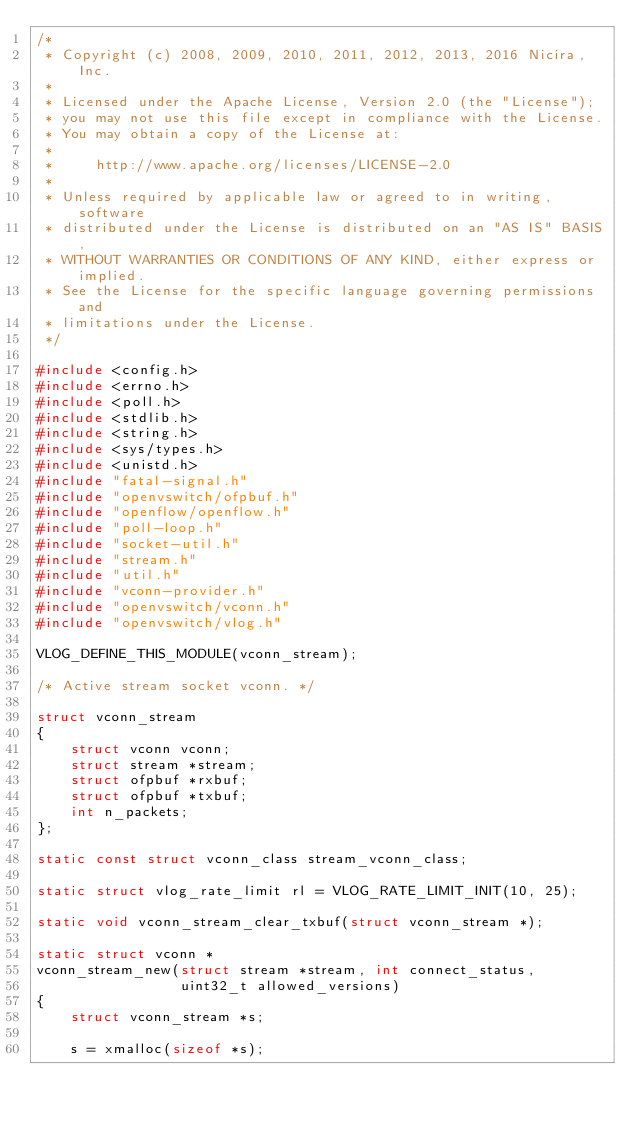<code> <loc_0><loc_0><loc_500><loc_500><_C_>/*
 * Copyright (c) 2008, 2009, 2010, 2011, 2012, 2013, 2016 Nicira, Inc.
 *
 * Licensed under the Apache License, Version 2.0 (the "License");
 * you may not use this file except in compliance with the License.
 * You may obtain a copy of the License at:
 *
 *     http://www.apache.org/licenses/LICENSE-2.0
 *
 * Unless required by applicable law or agreed to in writing, software
 * distributed under the License is distributed on an "AS IS" BASIS,
 * WITHOUT WARRANTIES OR CONDITIONS OF ANY KIND, either express or implied.
 * See the License for the specific language governing permissions and
 * limitations under the License.
 */

#include <config.h>
#include <errno.h>
#include <poll.h>
#include <stdlib.h>
#include <string.h>
#include <sys/types.h>
#include <unistd.h>
#include "fatal-signal.h"
#include "openvswitch/ofpbuf.h"
#include "openflow/openflow.h"
#include "poll-loop.h"
#include "socket-util.h"
#include "stream.h"
#include "util.h"
#include "vconn-provider.h"
#include "openvswitch/vconn.h"
#include "openvswitch/vlog.h"

VLOG_DEFINE_THIS_MODULE(vconn_stream);

/* Active stream socket vconn. */

struct vconn_stream
{
    struct vconn vconn;
    struct stream *stream;
    struct ofpbuf *rxbuf;
    struct ofpbuf *txbuf;
    int n_packets;
};

static const struct vconn_class stream_vconn_class;

static struct vlog_rate_limit rl = VLOG_RATE_LIMIT_INIT(10, 25);

static void vconn_stream_clear_txbuf(struct vconn_stream *);

static struct vconn *
vconn_stream_new(struct stream *stream, int connect_status,
                 uint32_t allowed_versions)
{
    struct vconn_stream *s;

    s = xmalloc(sizeof *s);</code> 